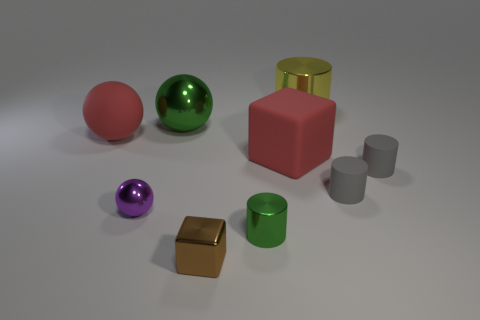Are there any matte objects that have the same size as the red sphere?
Offer a terse response. Yes. Is the number of tiny metal cylinders in front of the small green cylinder less than the number of big brown metal blocks?
Ensure brevity in your answer.  No. Does the matte ball have the same size as the yellow shiny thing?
Your response must be concise. Yes. What size is the block that is made of the same material as the green cylinder?
Your answer should be compact. Small. How many other small spheres are the same color as the matte ball?
Ensure brevity in your answer.  0. Are there fewer small green cylinders that are on the left side of the purple sphere than matte objects on the right side of the large matte cube?
Your answer should be compact. Yes. Do the big metallic thing that is left of the yellow cylinder and the tiny purple object have the same shape?
Provide a short and direct response. Yes. Do the cylinder left of the big yellow cylinder and the large yellow cylinder have the same material?
Your response must be concise. Yes. What material is the green thing that is behind the tiny object that is to the left of the large metal thing left of the yellow metallic thing?
Make the answer very short. Metal. How many other things are the same shape as the large green thing?
Keep it short and to the point. 2. 